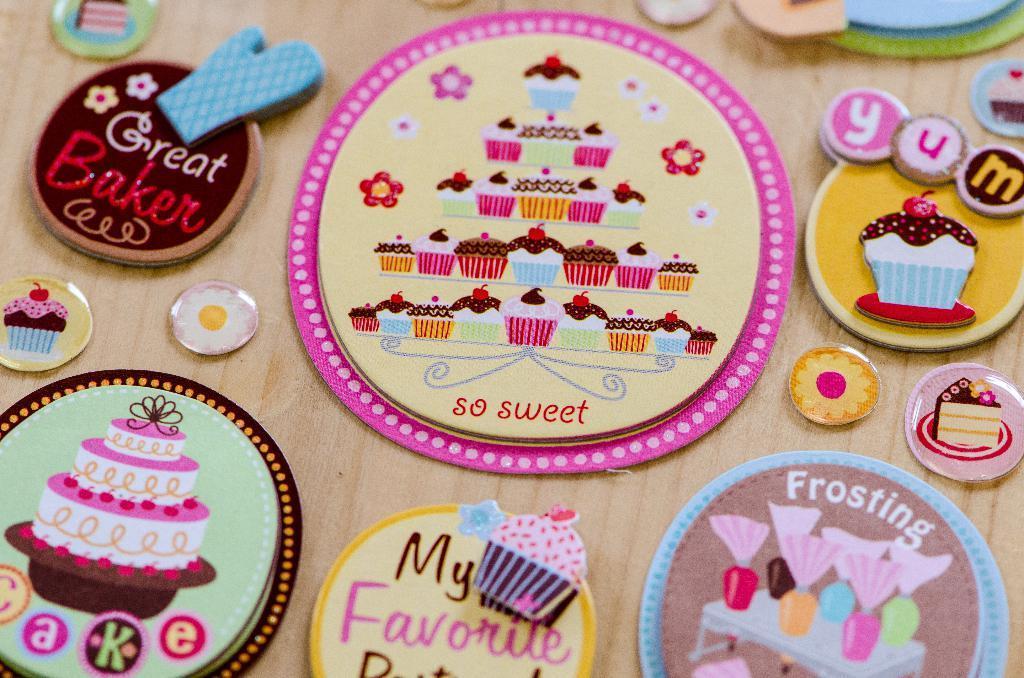How would you summarize this image in a sentence or two? In this image we can see few handcrafts. There is a wooden surface in the image. 